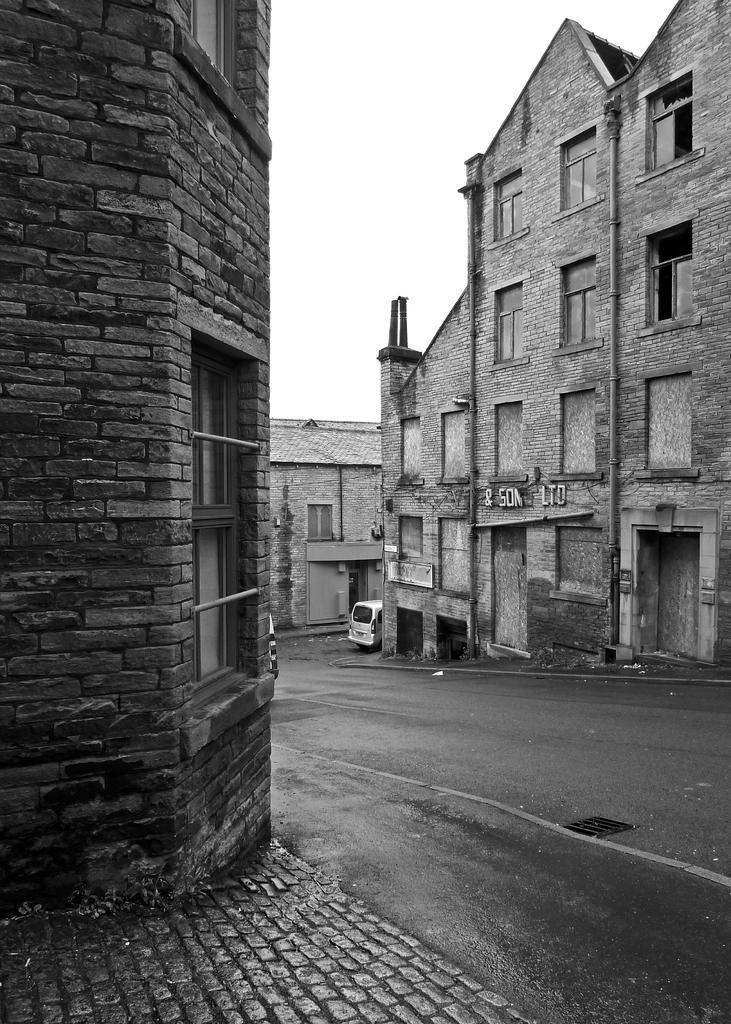Could you give a brief overview of what you see in this image? In the picture we can see a road on the either sides of the road we can see a path and buildings with windows and glasses in it and in the background also we can see another building and behind it we can see a sky. 